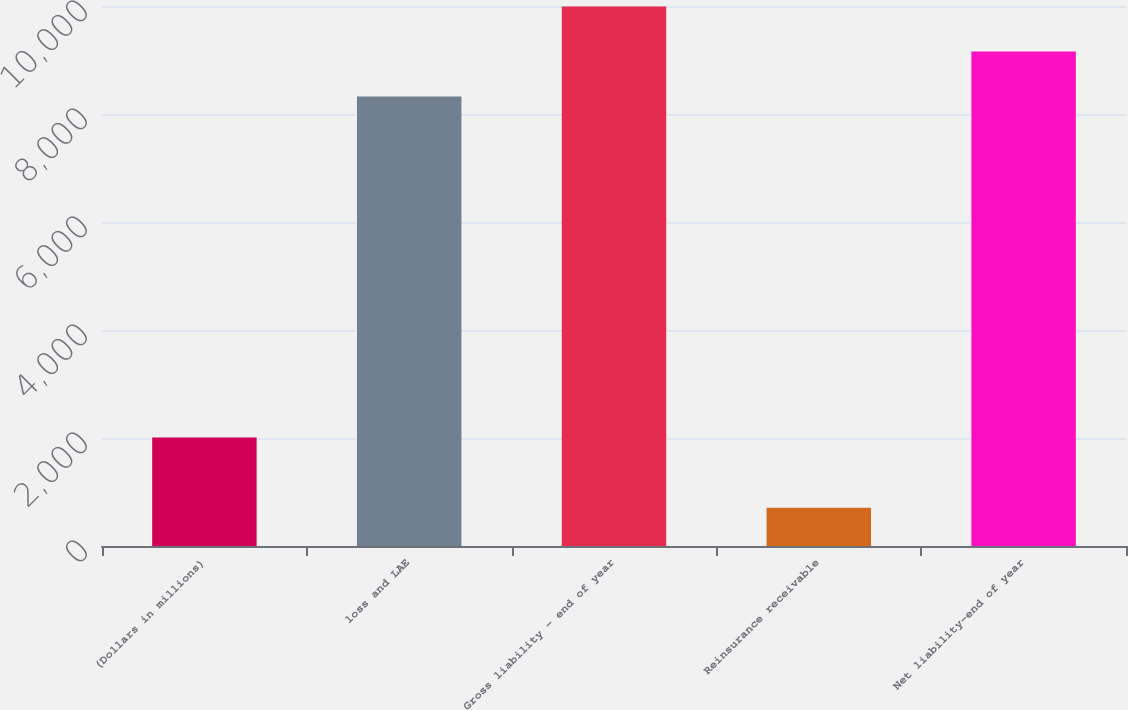Convert chart to OTSL. <chart><loc_0><loc_0><loc_500><loc_500><bar_chart><fcel>(Dollars in millions)<fcel>loss and LAE<fcel>Gross liability - end of year<fcel>Reinsurance receivable<fcel>Net liability-end of year<nl><fcel>2007<fcel>8324.7<fcel>9989.66<fcel>707.4<fcel>9157.18<nl></chart> 